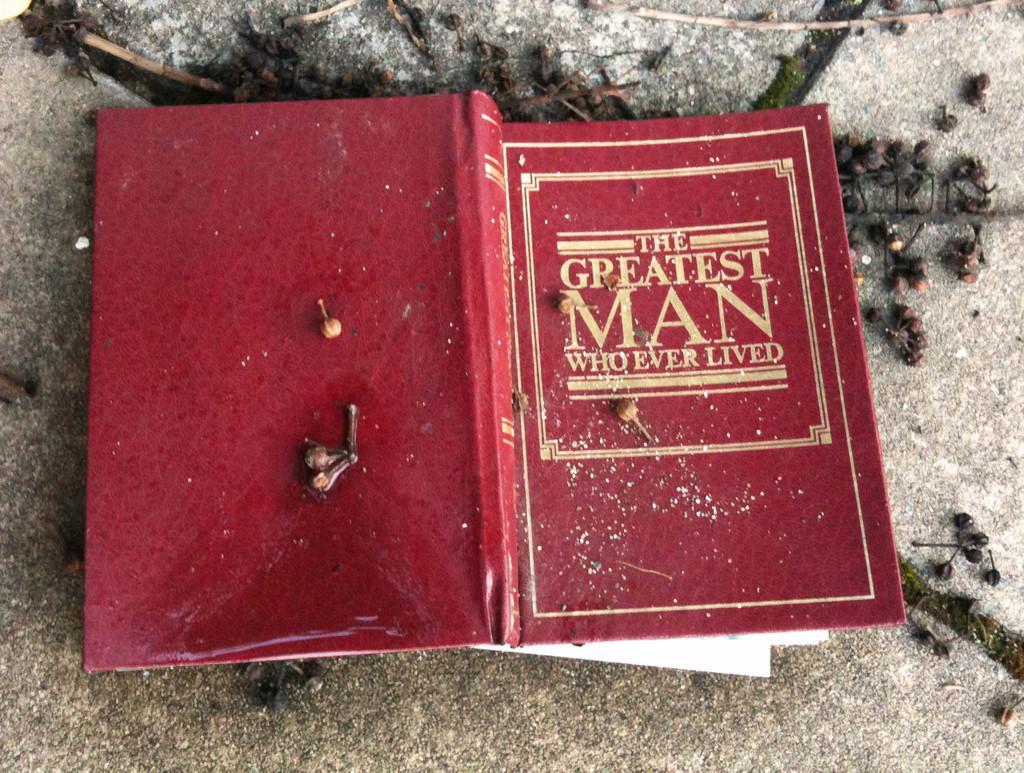Describe this image in one or two sentences. In this image there is a book which is red in colour and there is some text written on the book and there are objects which are black in colour. 